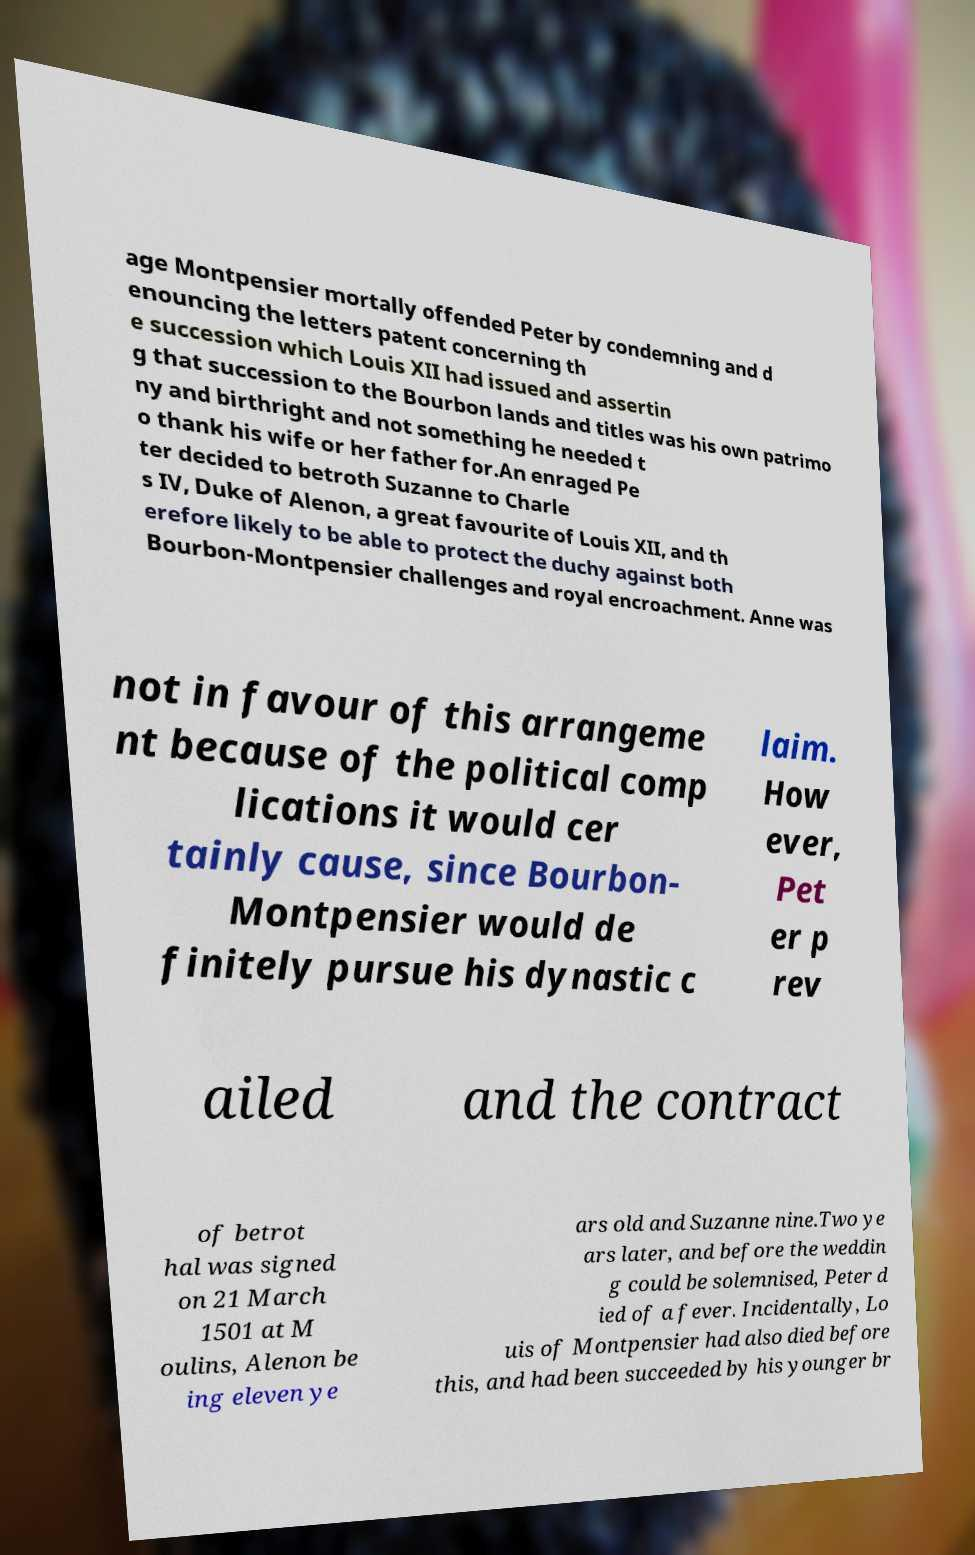Could you extract and type out the text from this image? age Montpensier mortally offended Peter by condemning and d enouncing the letters patent concerning th e succession which Louis XII had issued and assertin g that succession to the Bourbon lands and titles was his own patrimo ny and birthright and not something he needed t o thank his wife or her father for.An enraged Pe ter decided to betroth Suzanne to Charle s IV, Duke of Alenon, a great favourite of Louis XII, and th erefore likely to be able to protect the duchy against both Bourbon-Montpensier challenges and royal encroachment. Anne was not in favour of this arrangeme nt because of the political comp lications it would cer tainly cause, since Bourbon- Montpensier would de finitely pursue his dynastic c laim. How ever, Pet er p rev ailed and the contract of betrot hal was signed on 21 March 1501 at M oulins, Alenon be ing eleven ye ars old and Suzanne nine.Two ye ars later, and before the weddin g could be solemnised, Peter d ied of a fever. Incidentally, Lo uis of Montpensier had also died before this, and had been succeeded by his younger br 